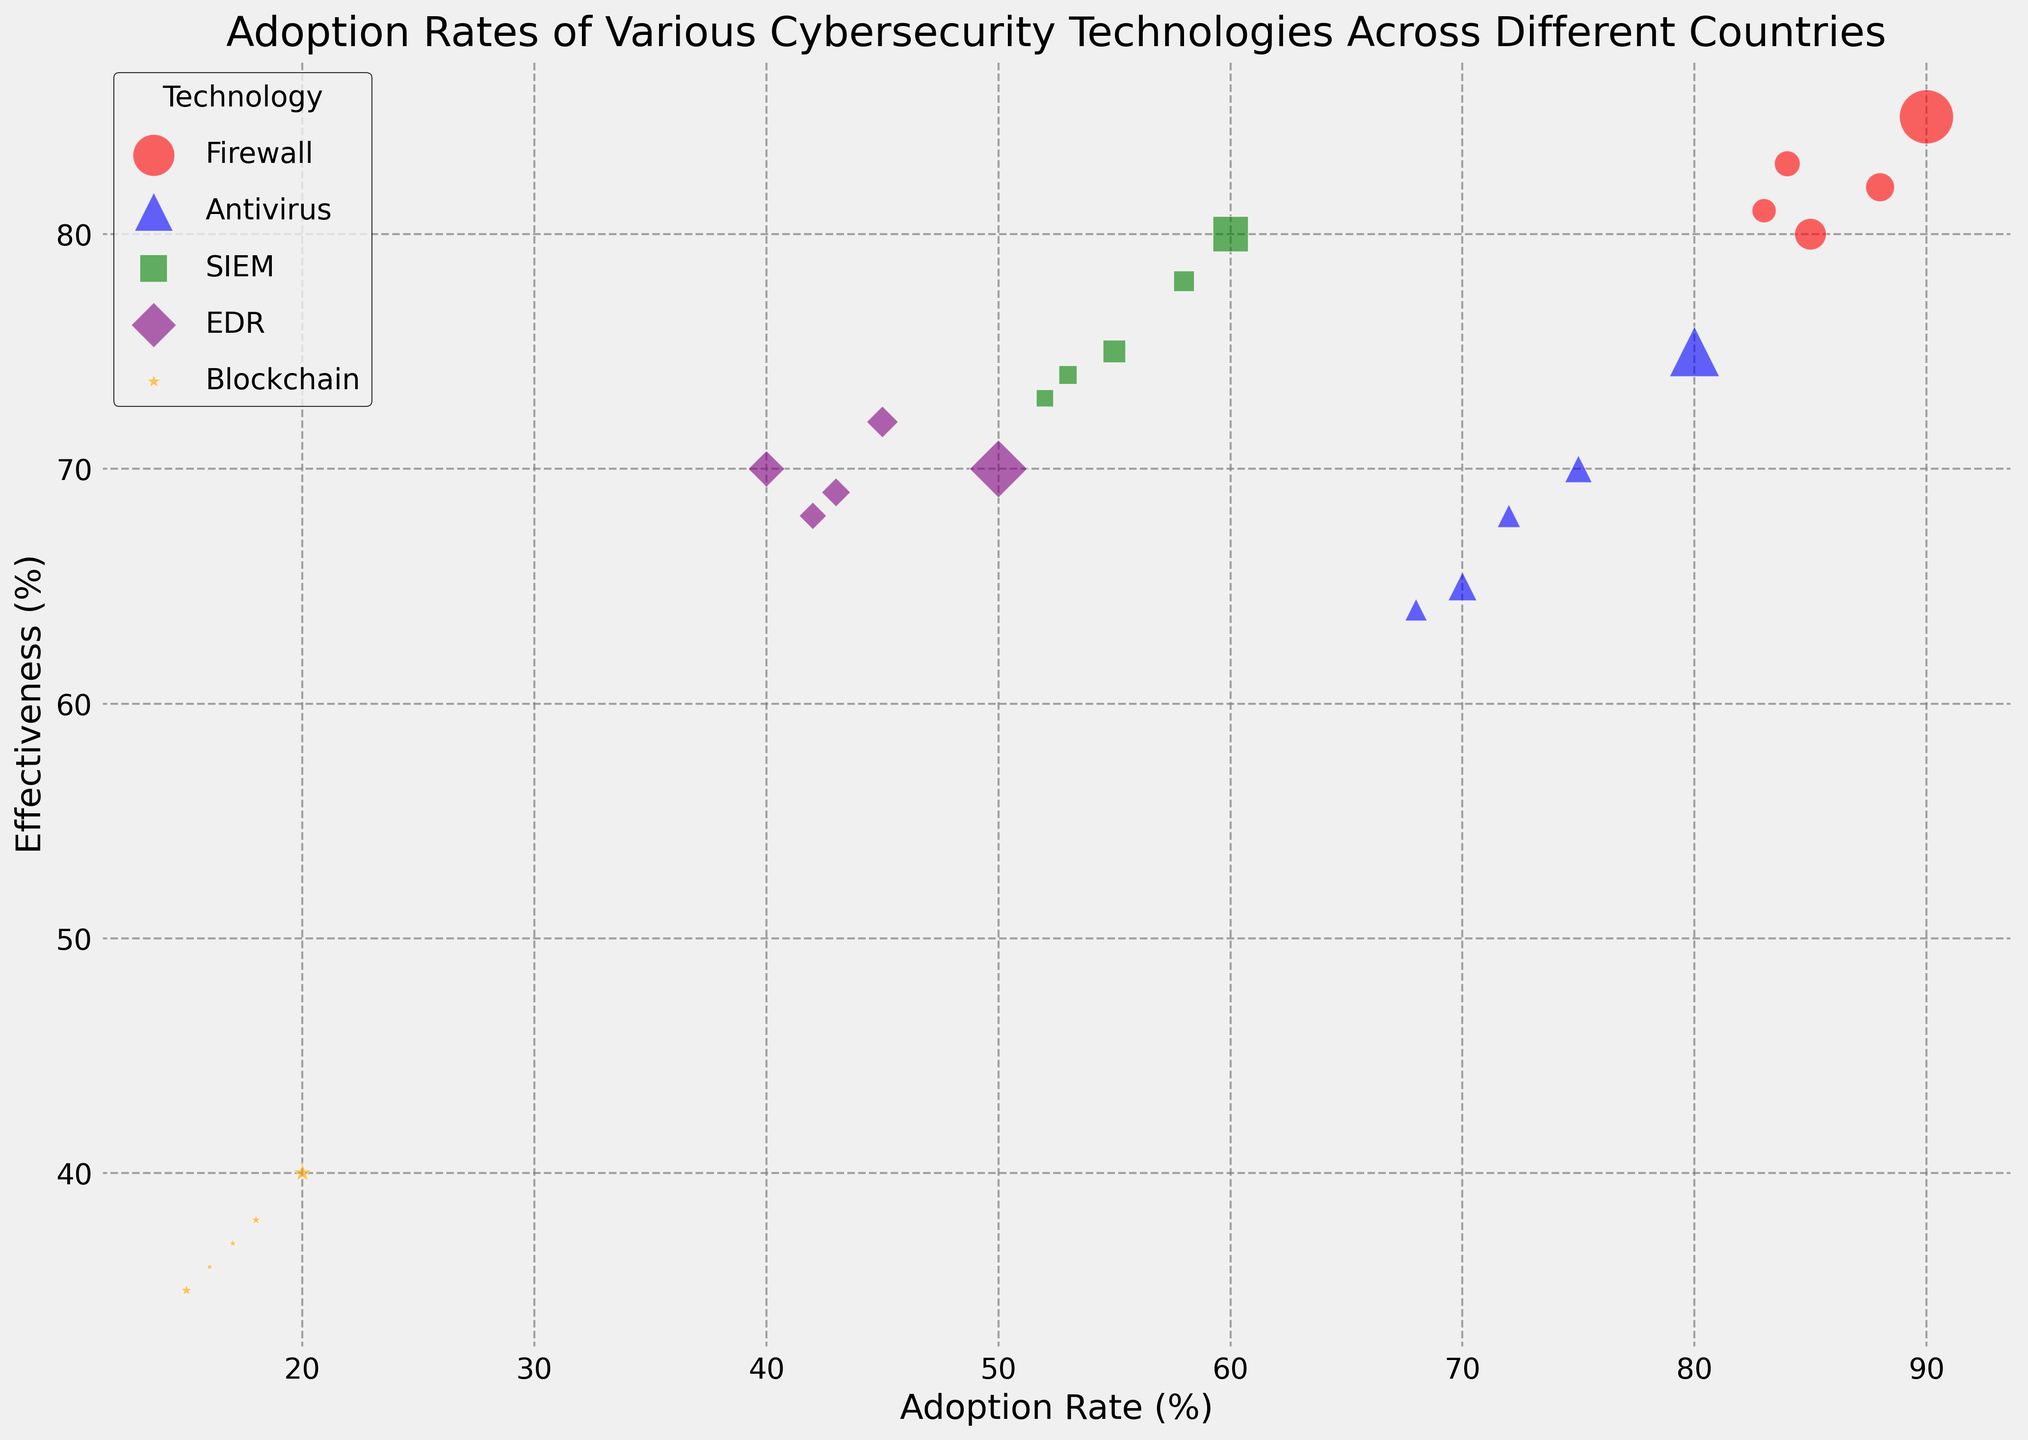Which cybersecurity technology has the highest adoption rate in the USA? The scatter plot shows the adoption rates on the x-axis. By looking at the USA data points, the Firewall technology has the highest adoption rate at 90%.
Answer: Firewall How does the effectiveness of Blockchain compare to SIEM in Australia? Compare the y-axis values for both technologies in the plot. Blockchain has an effectiveness of 36%, while SIEM has an effectiveness of 73%. Blockchain is significantly less effective than SIEM.
Answer: Blockchain is less effective Which technology has the smallest deployment size in Germany? Check the size of the bubbles for Germany. The smallest bubble corresponds to Blockchain with a deployment size of 1000.
Answer: Blockchain What is the difference in adoption rates between Firewalls and Anti-virus in Canada? Find the x-axis values for Firewalls and Anti-virus in the Canada data. Firewall adoption rate is 85%, and Anti-virus adoption rate is 70%. The difference is 85% - 70% = 15%.
Answer: 15% Which technology has the largest bubble in the USA and what does that represent? The largest bubble represents the largest deployment size. For the USA, the Firewall technology has the largest bubble, representing a deployment size of 35,000.
Answer: Firewall, 35,000 What can be inferred about the effectiveness of Blockchain across all countries? Observe all the orange bubbles representing Blockchain. They are consistently positioned lower on the y-axis, indicating low effectiveness. Blockchain is generally less effective across all shown countries.
Answer: Generally low effectiveness Compare the adoption rates of EDR in the UK and Germany. Which country has a higher rate? Locate the EDR data points for the UK and Germany on the x-axis. The UK has an adoption rate of 45%, and Germany has an adoption rate of 43%. The UK has a higher rate.
Answer: UK Is there any technology that varies greatly in adoption rate but remains relatively consistent in effectiveness? Observe the scatter plot for technologies with varying x-axis (adoption rate) but consistent y-axis (effectiveness). Firewall seems to have varying adoption rates between 83% and 90%, but its effectiveness is consistently high between 80% and 85%.
Answer: Firewall What is the average effectiveness of Antivirus across all countries? Sum the effectiveness values of Antivirus for all countries (75% + 65% + 70% + 68% + 64%) and divide by the number of countries (5). The average effectiveness is (75+65+70+68+64)/5 = 68.4%.
Answer: 68.4% Compare the deployment sizes of SIEM in the USA and Canada. Which country has a larger deployment? Observe the bubble sizes for SIEM in the USA and Canada. The USA has a deployment size of 15,000, while Canada has 6,000. The USA has a larger deployment.
Answer: USA 